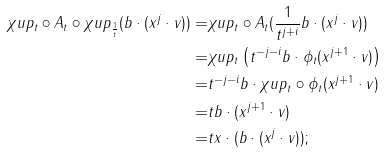<formula> <loc_0><loc_0><loc_500><loc_500>\chi u p _ { t } \circ A _ { t } \circ \chi u p _ { \frac { 1 } { t } } ( b \cdot ( x ^ { j } \cdot v ) ) = & \chi u p _ { t } \circ A _ { t } ( \frac { 1 } { t ^ { j + i } } b \cdot ( x ^ { j } \cdot v ) ) \\ = & \chi u p _ { t } \left ( t ^ { - j - i } b \cdot \phi _ { t } ( x ^ { j + 1 } \cdot v ) \right ) \\ = & t ^ { - j - i } b \cdot \chi u p _ { t } \circ \phi _ { t } ( x ^ { j + 1 } \cdot v ) \\ = & t b \cdot ( x ^ { j + 1 } \cdot v ) \\ = & t x \cdot ( b \cdot ( x ^ { j } \cdot v ) ) ; \\</formula> 